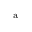Convert formula to latex. <formula><loc_0><loc_0><loc_500><loc_500>^ { a }</formula> 